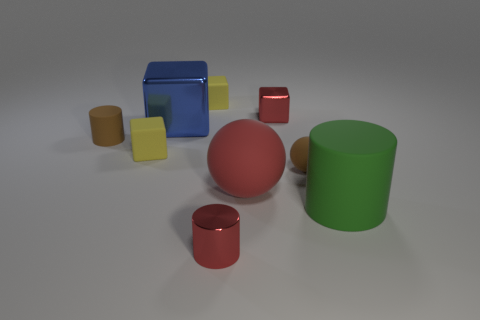What is the material of the red thing that is the same size as the blue thing?
Offer a terse response. Rubber. Are there any blue spheres that have the same material as the large green cylinder?
Your response must be concise. No. There is a blue object; does it have the same shape as the tiny shiny thing in front of the brown cylinder?
Offer a terse response. No. How many things are both in front of the blue metal object and on the left side of the large green cylinder?
Ensure brevity in your answer.  5. Are the large block and the brown thing that is on the right side of the metallic cylinder made of the same material?
Ensure brevity in your answer.  No. Is the number of red objects that are behind the small rubber ball the same as the number of big rubber spheres?
Keep it short and to the point. Yes. There is a tiny cylinder that is behind the red cylinder; what is its color?
Give a very brief answer. Brown. How many other things are there of the same color as the large sphere?
Make the answer very short. 2. Is there any other thing that has the same size as the red shiny cube?
Your answer should be very brief. Yes. There is a green matte thing to the right of the red cylinder; is its size the same as the large red matte thing?
Offer a terse response. Yes. 